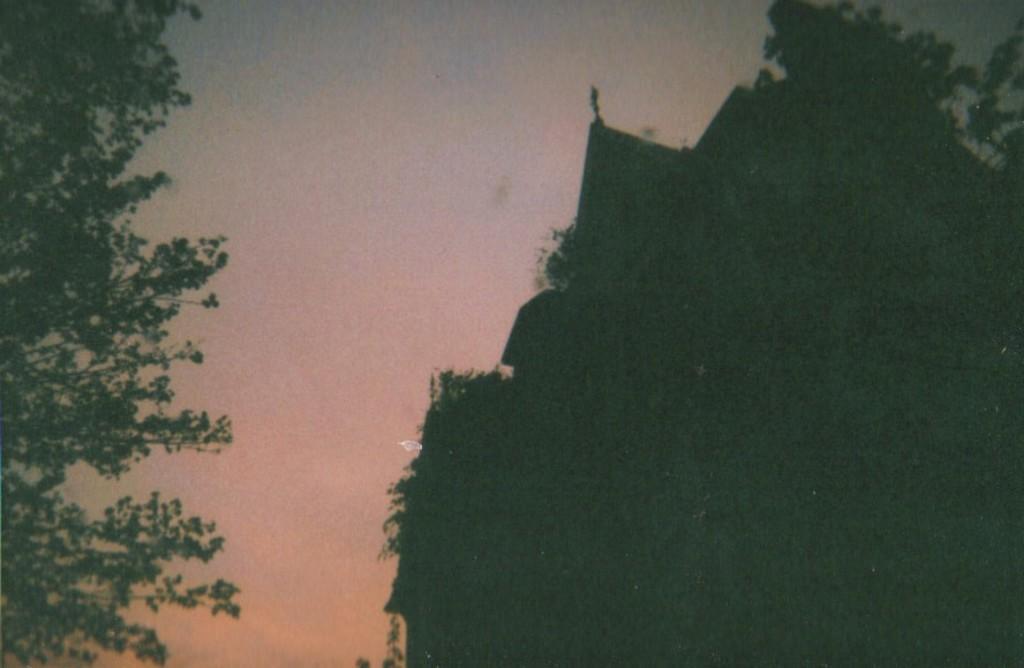Can you describe this image briefly? We can see trees on the right side of this image and on the left side of this image as well. The sky is in the background. 